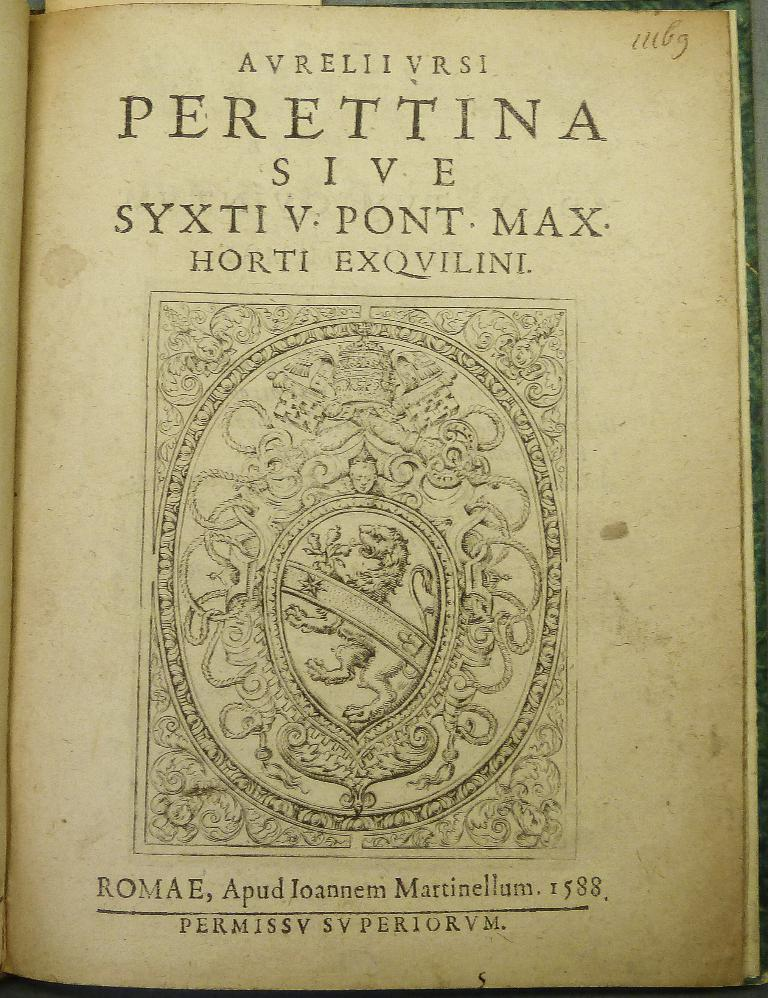<image>
Render a clear and concise summary of the photo. A book that was written in 1588 is open to the first page. 